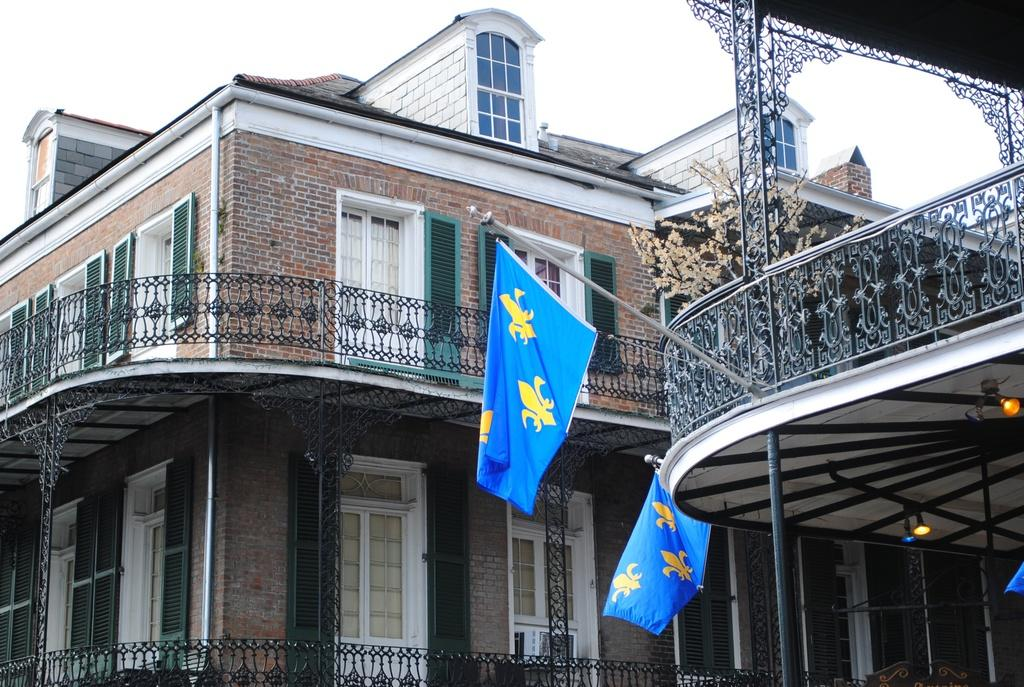What can be seen in the foreground of the image? There are two flags in the foreground of the image. Where are the flags attached? The flags are attached to a building. What is visible in the background of the image? There is a building, a door, pipes, windows, and the sky visible in the background of the image. What type of circle is being drawn with a pen in the image? There is no circle or pen present in the image. What is the purpose of the mine in the image? There is no mine present in the image. 